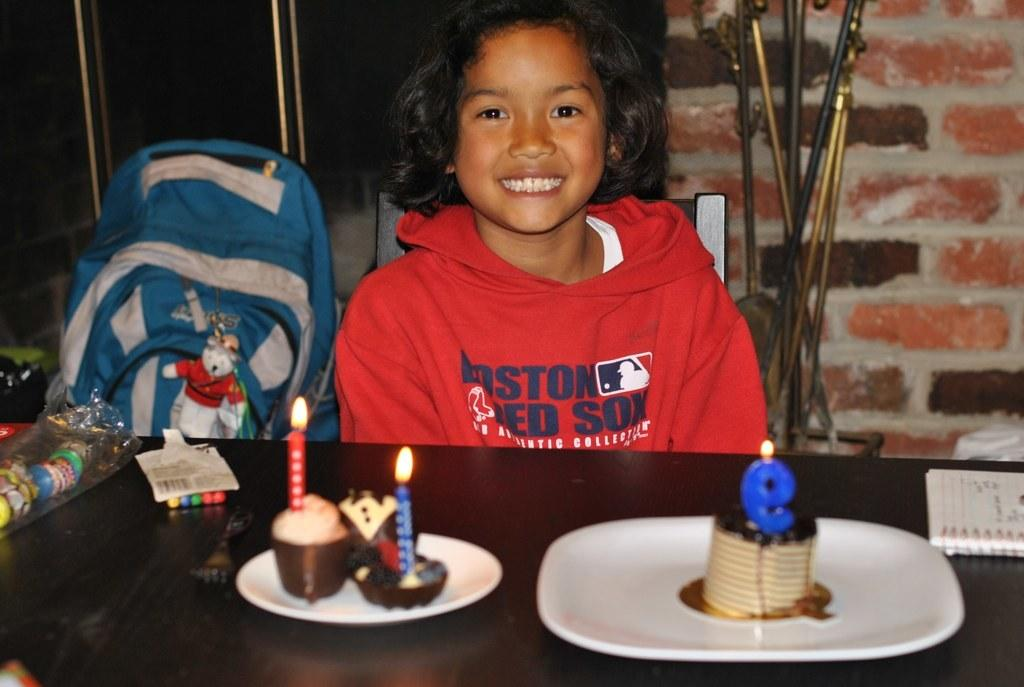Who is in the image? There is a girl in the image. What is the girl doing in the image? The girl is sitting on a chair and smiling. What is on the plate in the image? There is a cake on a plate in the image. What object is beside the girl? There is a bag beside the girl. What can be seen in the background of the image? There is a wall and a flower pot in the background of the image. What type of crack is visible on the girl's face in the image? There is no crack visible on the girl's face in the image. 